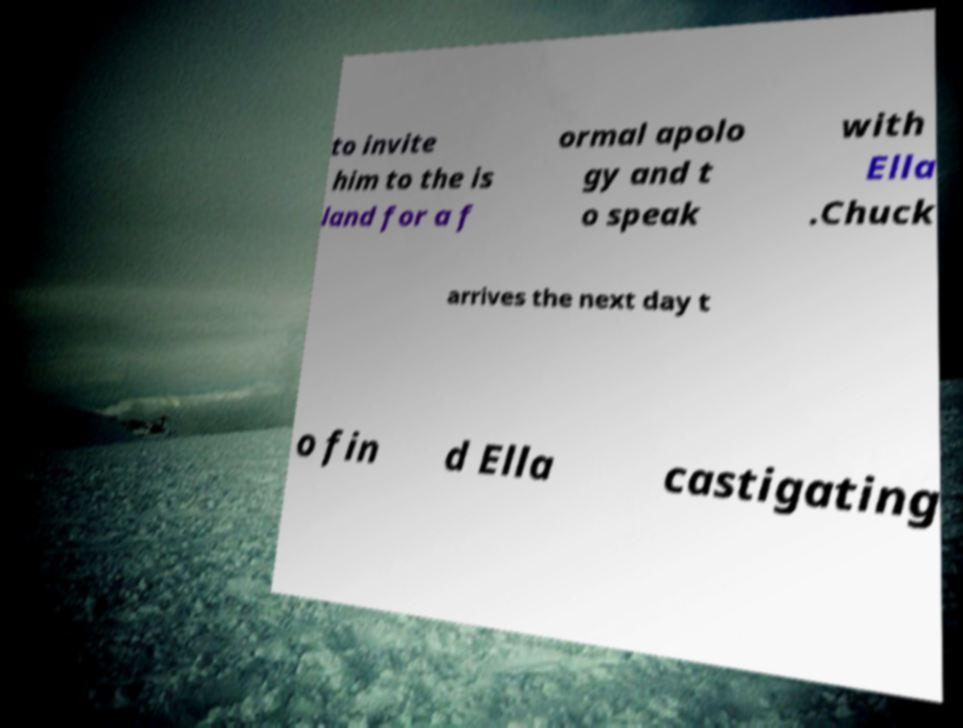Could you assist in decoding the text presented in this image and type it out clearly? to invite him to the is land for a f ormal apolo gy and t o speak with Ella .Chuck arrives the next day t o fin d Ella castigating 